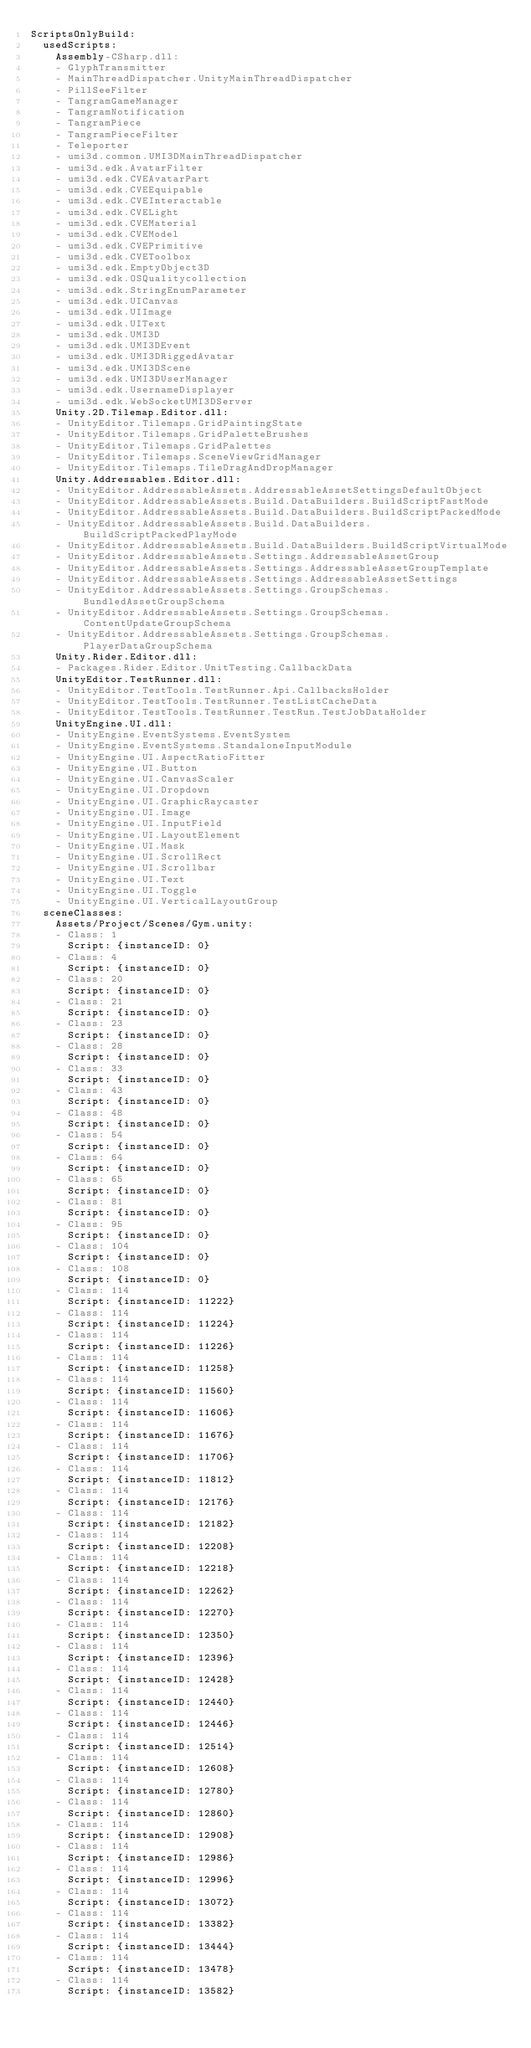Convert code to text. <code><loc_0><loc_0><loc_500><loc_500><_YAML_>ScriptsOnlyBuild:
  usedScripts:
    Assembly-CSharp.dll:
    - GlyphTransmitter
    - MainThreadDispatcher.UnityMainThreadDispatcher
    - PillSeeFilter
    - TangramGameManager
    - TangramNotification
    - TangramPiece
    - TangramPieceFilter
    - Teleporter
    - umi3d.common.UMI3DMainThreadDispatcher
    - umi3d.edk.AvatarFilter
    - umi3d.edk.CVEAvatarPart
    - umi3d.edk.CVEEquipable
    - umi3d.edk.CVEInteractable
    - umi3d.edk.CVELight
    - umi3d.edk.CVEMaterial
    - umi3d.edk.CVEModel
    - umi3d.edk.CVEPrimitive
    - umi3d.edk.CVEToolbox
    - umi3d.edk.EmptyObject3D
    - umi3d.edk.OSQualitycollection
    - umi3d.edk.StringEnumParameter
    - umi3d.edk.UICanvas
    - umi3d.edk.UIImage
    - umi3d.edk.UIText
    - umi3d.edk.UMI3D
    - umi3d.edk.UMI3DEvent
    - umi3d.edk.UMI3DRiggedAvatar
    - umi3d.edk.UMI3DScene
    - umi3d.edk.UMI3DUserManager
    - umi3d.edk.UsernameDisplayer
    - umi3d.edk.WebSocketUMI3DServer
    Unity.2D.Tilemap.Editor.dll:
    - UnityEditor.Tilemaps.GridPaintingState
    - UnityEditor.Tilemaps.GridPaletteBrushes
    - UnityEditor.Tilemaps.GridPalettes
    - UnityEditor.Tilemaps.SceneViewGridManager
    - UnityEditor.Tilemaps.TileDragAndDropManager
    Unity.Addressables.Editor.dll:
    - UnityEditor.AddressableAssets.AddressableAssetSettingsDefaultObject
    - UnityEditor.AddressableAssets.Build.DataBuilders.BuildScriptFastMode
    - UnityEditor.AddressableAssets.Build.DataBuilders.BuildScriptPackedMode
    - UnityEditor.AddressableAssets.Build.DataBuilders.BuildScriptPackedPlayMode
    - UnityEditor.AddressableAssets.Build.DataBuilders.BuildScriptVirtualMode
    - UnityEditor.AddressableAssets.Settings.AddressableAssetGroup
    - UnityEditor.AddressableAssets.Settings.AddressableAssetGroupTemplate
    - UnityEditor.AddressableAssets.Settings.AddressableAssetSettings
    - UnityEditor.AddressableAssets.Settings.GroupSchemas.BundledAssetGroupSchema
    - UnityEditor.AddressableAssets.Settings.GroupSchemas.ContentUpdateGroupSchema
    - UnityEditor.AddressableAssets.Settings.GroupSchemas.PlayerDataGroupSchema
    Unity.Rider.Editor.dll:
    - Packages.Rider.Editor.UnitTesting.CallbackData
    UnityEditor.TestRunner.dll:
    - UnityEditor.TestTools.TestRunner.Api.CallbacksHolder
    - UnityEditor.TestTools.TestRunner.TestListCacheData
    - UnityEditor.TestTools.TestRunner.TestRun.TestJobDataHolder
    UnityEngine.UI.dll:
    - UnityEngine.EventSystems.EventSystem
    - UnityEngine.EventSystems.StandaloneInputModule
    - UnityEngine.UI.AspectRatioFitter
    - UnityEngine.UI.Button
    - UnityEngine.UI.CanvasScaler
    - UnityEngine.UI.Dropdown
    - UnityEngine.UI.GraphicRaycaster
    - UnityEngine.UI.Image
    - UnityEngine.UI.InputField
    - UnityEngine.UI.LayoutElement
    - UnityEngine.UI.Mask
    - UnityEngine.UI.ScrollRect
    - UnityEngine.UI.Scrollbar
    - UnityEngine.UI.Text
    - UnityEngine.UI.Toggle
    - UnityEngine.UI.VerticalLayoutGroup
  sceneClasses:
    Assets/Project/Scenes/Gym.unity:
    - Class: 1
      Script: {instanceID: 0}
    - Class: 4
      Script: {instanceID: 0}
    - Class: 20
      Script: {instanceID: 0}
    - Class: 21
      Script: {instanceID: 0}
    - Class: 23
      Script: {instanceID: 0}
    - Class: 28
      Script: {instanceID: 0}
    - Class: 33
      Script: {instanceID: 0}
    - Class: 43
      Script: {instanceID: 0}
    - Class: 48
      Script: {instanceID: 0}
    - Class: 54
      Script: {instanceID: 0}
    - Class: 64
      Script: {instanceID: 0}
    - Class: 65
      Script: {instanceID: 0}
    - Class: 81
      Script: {instanceID: 0}
    - Class: 95
      Script: {instanceID: 0}
    - Class: 104
      Script: {instanceID: 0}
    - Class: 108
      Script: {instanceID: 0}
    - Class: 114
      Script: {instanceID: 11222}
    - Class: 114
      Script: {instanceID: 11224}
    - Class: 114
      Script: {instanceID: 11226}
    - Class: 114
      Script: {instanceID: 11258}
    - Class: 114
      Script: {instanceID: 11560}
    - Class: 114
      Script: {instanceID: 11606}
    - Class: 114
      Script: {instanceID: 11676}
    - Class: 114
      Script: {instanceID: 11706}
    - Class: 114
      Script: {instanceID: 11812}
    - Class: 114
      Script: {instanceID: 12176}
    - Class: 114
      Script: {instanceID: 12182}
    - Class: 114
      Script: {instanceID: 12208}
    - Class: 114
      Script: {instanceID: 12218}
    - Class: 114
      Script: {instanceID: 12262}
    - Class: 114
      Script: {instanceID: 12270}
    - Class: 114
      Script: {instanceID: 12350}
    - Class: 114
      Script: {instanceID: 12396}
    - Class: 114
      Script: {instanceID: 12428}
    - Class: 114
      Script: {instanceID: 12440}
    - Class: 114
      Script: {instanceID: 12446}
    - Class: 114
      Script: {instanceID: 12514}
    - Class: 114
      Script: {instanceID: 12608}
    - Class: 114
      Script: {instanceID: 12780}
    - Class: 114
      Script: {instanceID: 12860}
    - Class: 114
      Script: {instanceID: 12908}
    - Class: 114
      Script: {instanceID: 12986}
    - Class: 114
      Script: {instanceID: 12996}
    - Class: 114
      Script: {instanceID: 13072}
    - Class: 114
      Script: {instanceID: 13382}
    - Class: 114
      Script: {instanceID: 13444}
    - Class: 114
      Script: {instanceID: 13478}
    - Class: 114
      Script: {instanceID: 13582}</code> 